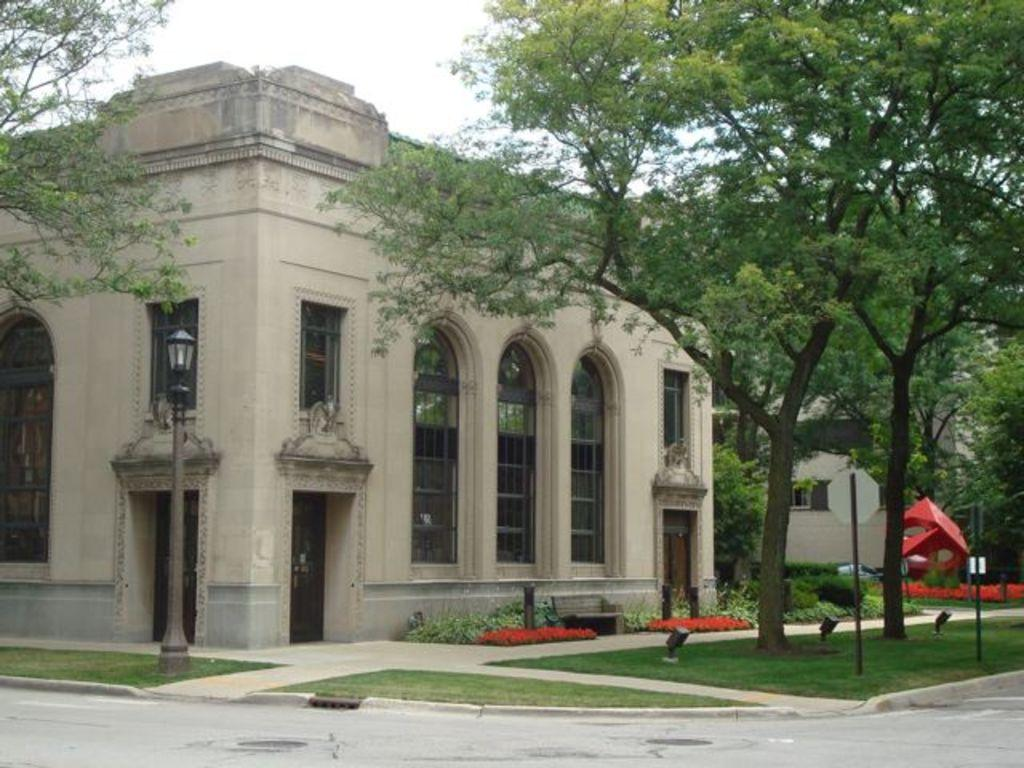What type of vertical structures can be seen in the image? There are light poles and poles in the image. What type of vegetation is present in the image? There is grass, shrubs, and trees in the image. What is visible in the background of the image? The sky is visible in the background of the image. Can you see any icicles hanging from the light poles in the image? There are no icicles present in the image; it appears to be a regular outdoor scene with light poles, grass, shrubs, trees, and a visible sky. 